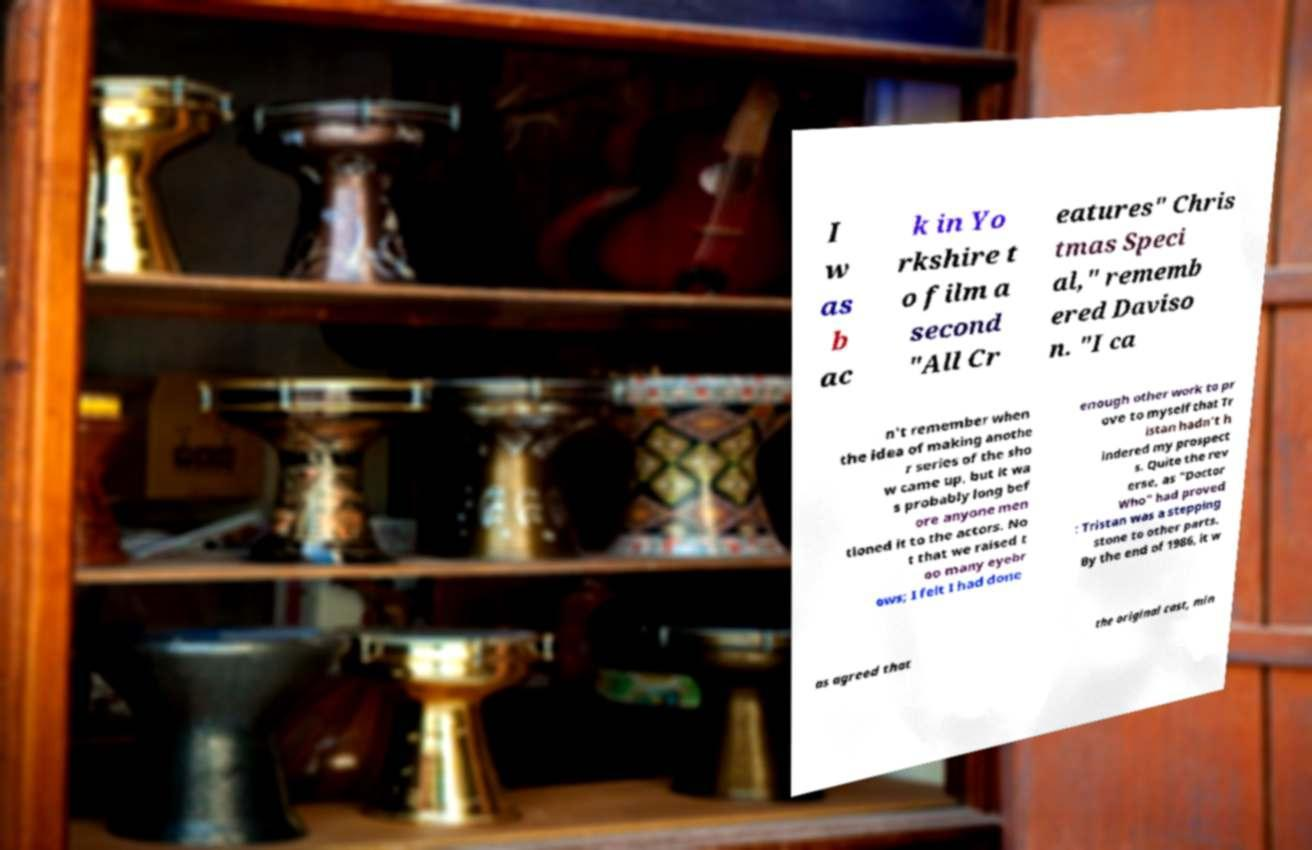Can you read and provide the text displayed in the image?This photo seems to have some interesting text. Can you extract and type it out for me? I w as b ac k in Yo rkshire t o film a second "All Cr eatures" Chris tmas Speci al," rememb ered Daviso n. "I ca n't remember when the idea of making anothe r series of the sho w came up, but it wa s probably long bef ore anyone men tioned it to the actors. No t that we raised t oo many eyebr ows; I felt I had done enough other work to pr ove to myself that Tr istan hadn't h indered my prospect s. Quite the rev erse, as "Doctor Who" had proved : Tristan was a stepping stone to other parts. By the end of 1986, it w as agreed that the original cast, min 